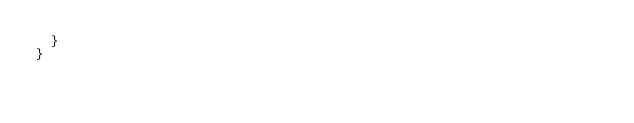<code> <loc_0><loc_0><loc_500><loc_500><_Kotlin_>  }
}
</code> 